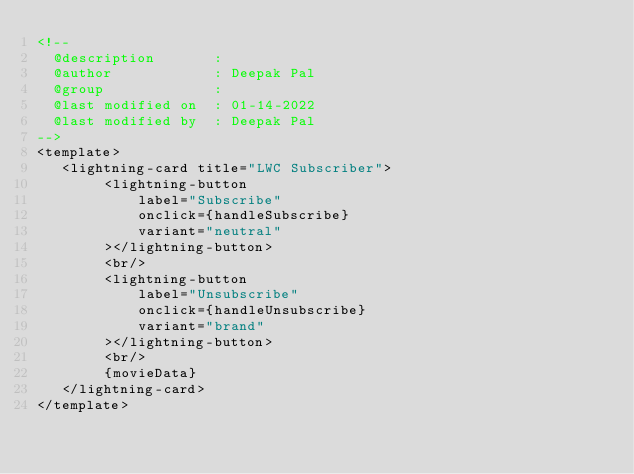<code> <loc_0><loc_0><loc_500><loc_500><_HTML_><!--
  @description       : 
  @author            : Deepak Pal
  @group             : 
  @last modified on  : 01-14-2022
  @last modified by  : Deepak Pal
-->
<template>
   <lightning-card title="LWC Subscriber">
        <lightning-button 
            label="Subscribe"
            onclick={handleSubscribe}
            variant="neutral"
        ></lightning-button>
        <br/>
        <lightning-button 
            label="Unsubscribe"
            onclick={handleUnsubscribe}
            variant="brand"
        ></lightning-button>
        <br/>
        {movieData}
   </lightning-card>
</template></code> 